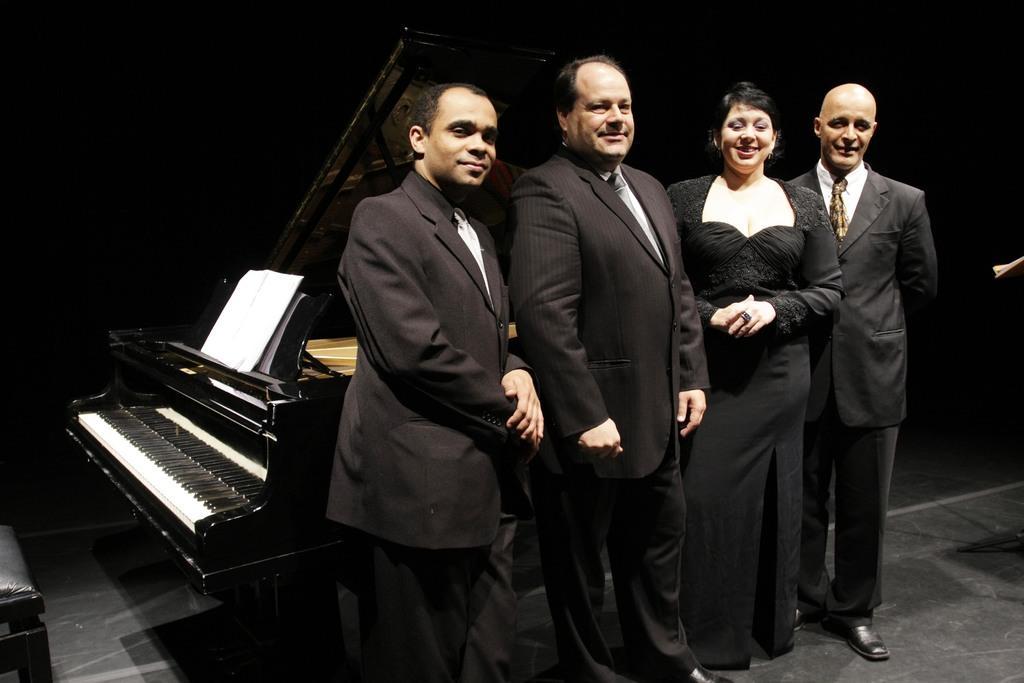Could you give a brief overview of what you see in this image? In this image i can see three men and a woman standing at the background there is a piano and a paper. 